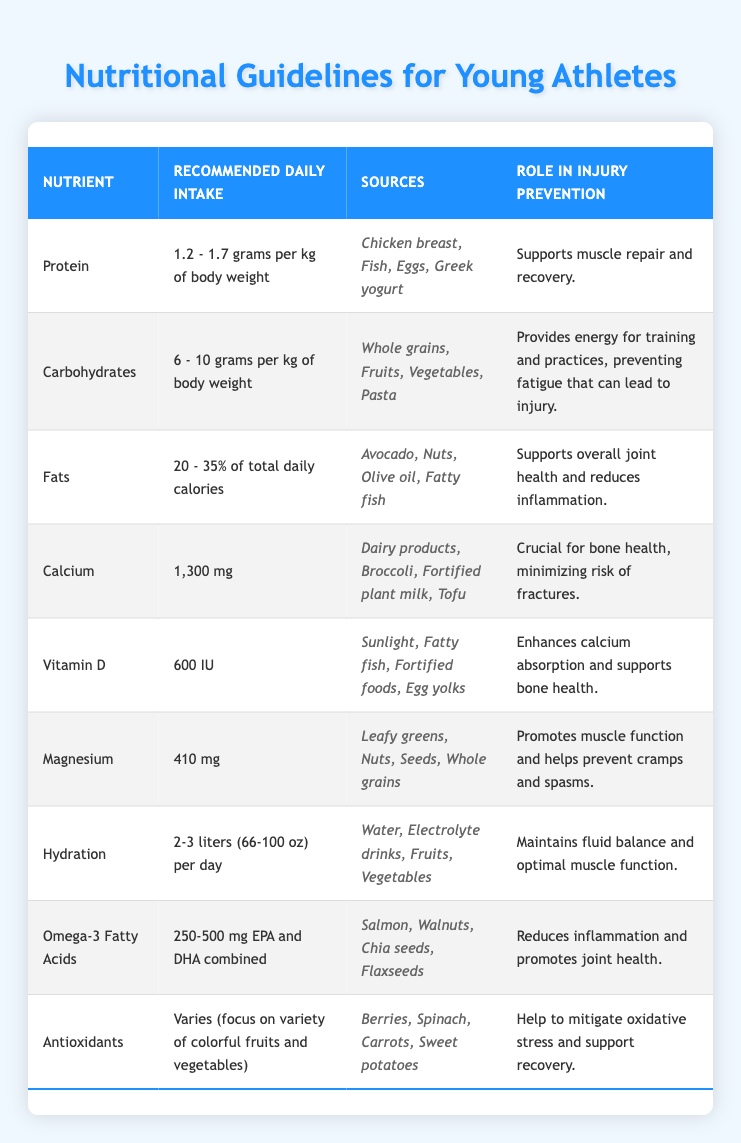What is the recommended daily intake of carbohydrates? The table specifies that the recommended daily intake of carbohydrates is 6 - 10 grams per kg of body weight. This can be found directly in the table under the "Recommended Daily Intake" column for the nutrient "Carbohydrates."
Answer: 6 - 10 grams per kg of body weight Which nutrient is crucial for bone health? In the table, "Calcium" is mentioned as crucial for bone health. This is stated under the "Role in Injury Prevention" for the nutrient "Calcium."
Answer: Calcium True or False: Omega-3 fatty acids are recommended to consume at 600 IU daily. The table lists the recommended intake for Omega-3 Fatty Acids as 250-500 mg EPA and DHA combined, not 600 IU. Therefore, the statement is false.
Answer: False What is the role of magnesium in injury prevention? According to the table, magnesium promotes muscle function and helps prevent cramps and spasms, as stated in the "Role in Injury Prevention" column for magnesium.
Answer: Promotes muscle function and helps prevent cramps and spasms If a young athlete weighs 70 kg, what is the minimum recommended daily intake of protein? The minimum recommended daily intake of protein is 1.2 grams per kg of body weight. For a 70 kg athlete, the calculation is 1.2 grams x 70 kg = 84 grams. Thus, the minimum intake is 84 grams per day.
Answer: 84 grams What is the percentage range for fat intake in a young athlete's diet? The table indicates that the recommended daily intake for fats is 20 - 35% of total daily calories. This percentage can be found under the "Recommended Daily Intake" for the nutrient "Fats."
Answer: 20 - 35% Which sources provide a good amount of vitamin D? The table lists the sources for vitamin D as sunlight, fatty fish, fortified foods, and egg yolks in the "Sources" column for the nutrient "Vitamin D."
Answer: Sunlight, fatty fish, fortified foods, egg yolks How many total liters of hydration does a young athlete need daily? The table states that the recommended daily intake for hydration is 2-3 liters (66-100 oz) per day, which can be found in the "Recommended Daily Intake" column for the nutrient "Hydration."
Answer: 2-3 liters (66-100 oz) per day What are two sources of antioxidants recommended for young athletes? The table lists berries, spinach, carrots, and sweet potatoes under the sources for antioxidants. Thus, any two of these items could be considered valid answers, such as berries and spinach.
Answer: Berries, spinach 